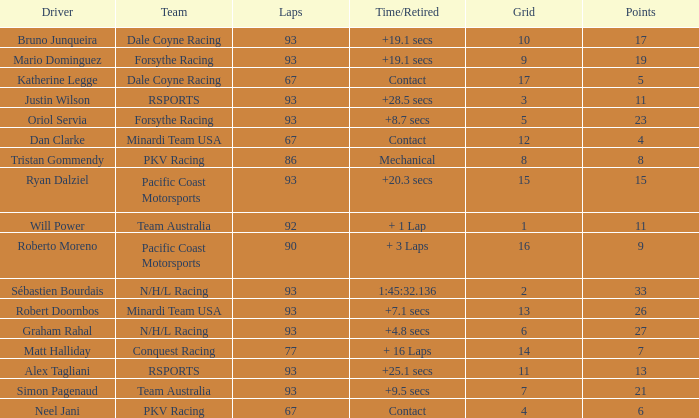What is the grid for the Minardi Team USA with laps smaller than 90? 12.0. 